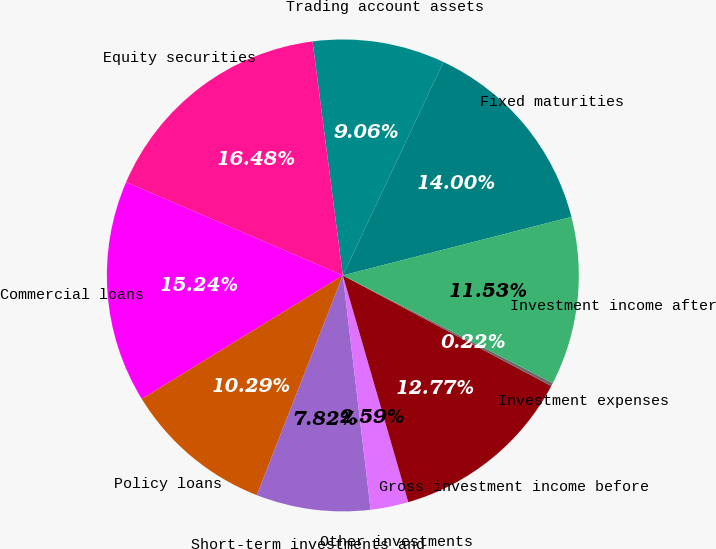Convert chart to OTSL. <chart><loc_0><loc_0><loc_500><loc_500><pie_chart><fcel>Fixed maturities<fcel>Trading account assets<fcel>Equity securities<fcel>Commercial loans<fcel>Policy loans<fcel>Short-term investments and<fcel>Other investments<fcel>Gross investment income before<fcel>Investment expenses<fcel>Investment income after<nl><fcel>14.0%<fcel>9.06%<fcel>16.48%<fcel>15.24%<fcel>10.29%<fcel>7.82%<fcel>2.59%<fcel>12.77%<fcel>0.22%<fcel>11.53%<nl></chart> 